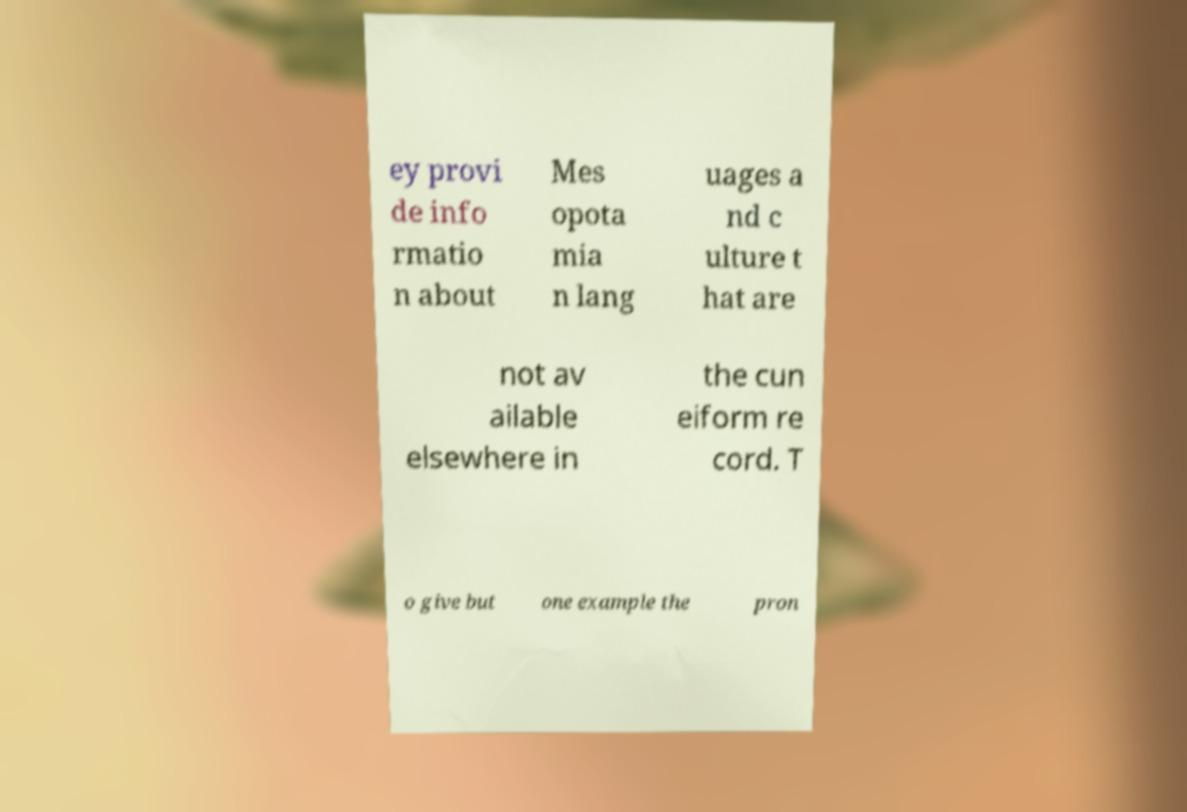Can you read and provide the text displayed in the image?This photo seems to have some interesting text. Can you extract and type it out for me? ey provi de info rmatio n about Mes opota mia n lang uages a nd c ulture t hat are not av ailable elsewhere in the cun eiform re cord. T o give but one example the pron 